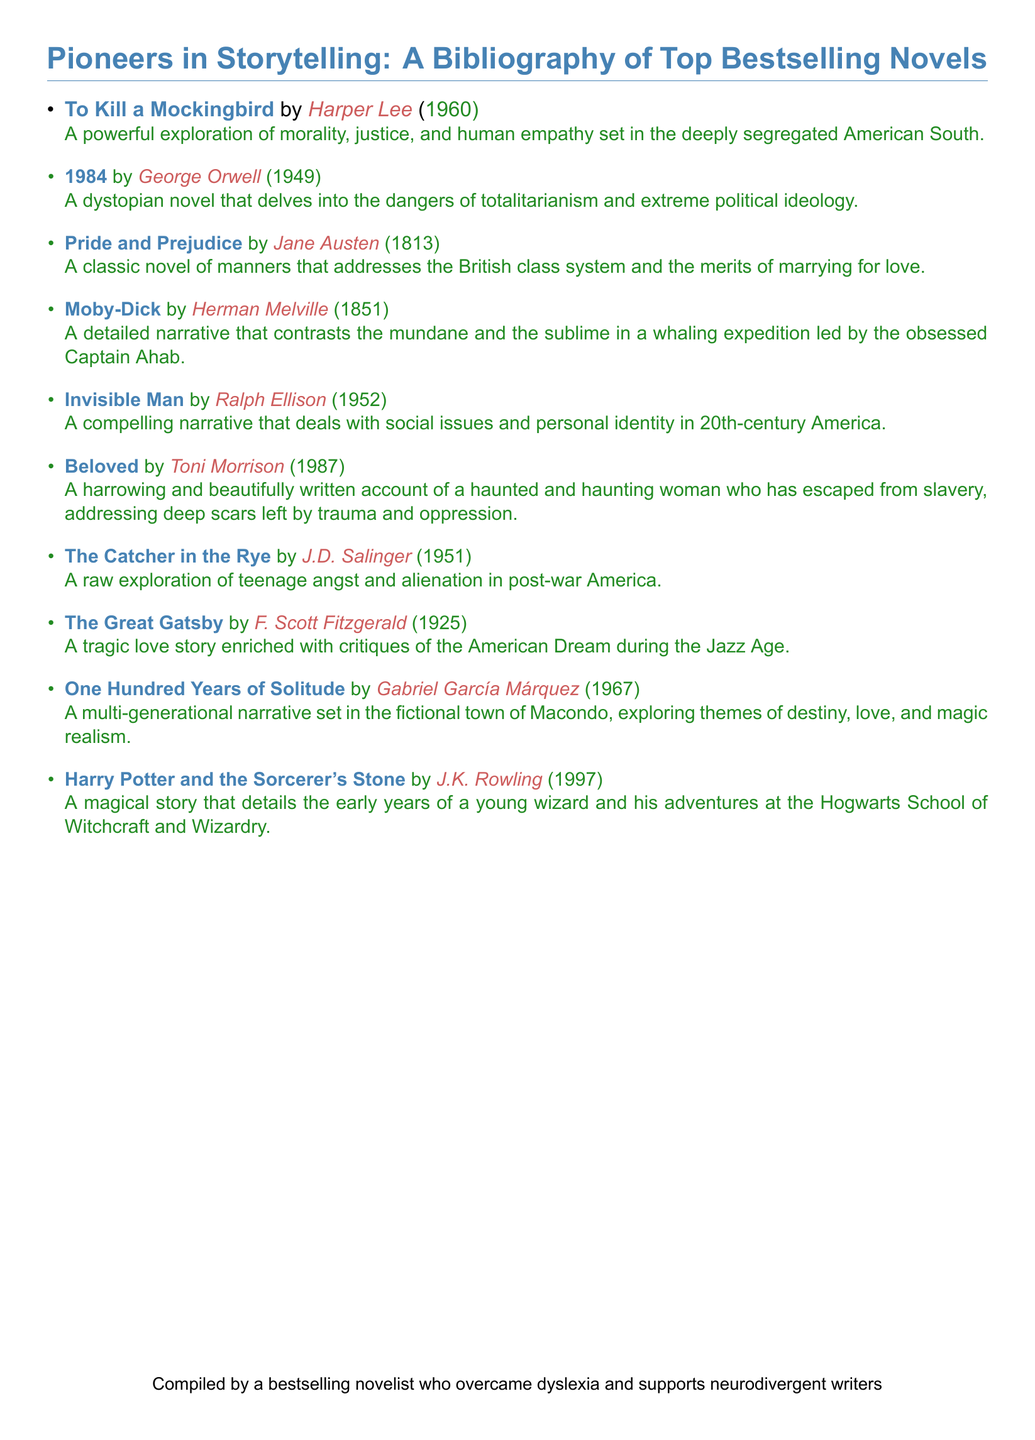What is the title of the earliest novel listed? The earliest novel listed is determined by the year of publication, which is 1813 for "Pride and Prejudice."
Answer: Pride and Prejudice Who is the author of "1984"? The author of "1984" is explicitly stated in the document as George Orwell.
Answer: George Orwell In what year was "Beloved" published? The publication year of "Beloved" is provided as 1987 in the document.
Answer: 1987 Which novel addresses themes of magic realism? The novel that explores themes of magic realism is noted as "One Hundred Years of Solitude."
Answer: One Hundred Years of Solitude What literary theme does "The Great Gatsby" critique? The document mentions that "The Great Gatsby" critiques the American Dream during the Jazz Age.
Answer: American Dream How many novels are included in the bibliography? Counting the entries, there are a total of ten novels included in the bibliography.
Answer: 10 What type of narrative is "To Kill a Mockingbird"? "To Kill a Mockingbird" is categorized as a powerful exploration of morality, justice, and human empathy.
Answer: Exploration of morality, justice, and human empathy Which novel features a character named Captain Ahab? The novel that features Captain Ahab is "Moby-Dick."
Answer: Moby-Dick What is the publication year of the latest novel listed? The latest novel listed is from 1997, which is when "Harry Potter and the Sorcerer's Stone" was published.
Answer: 1997 